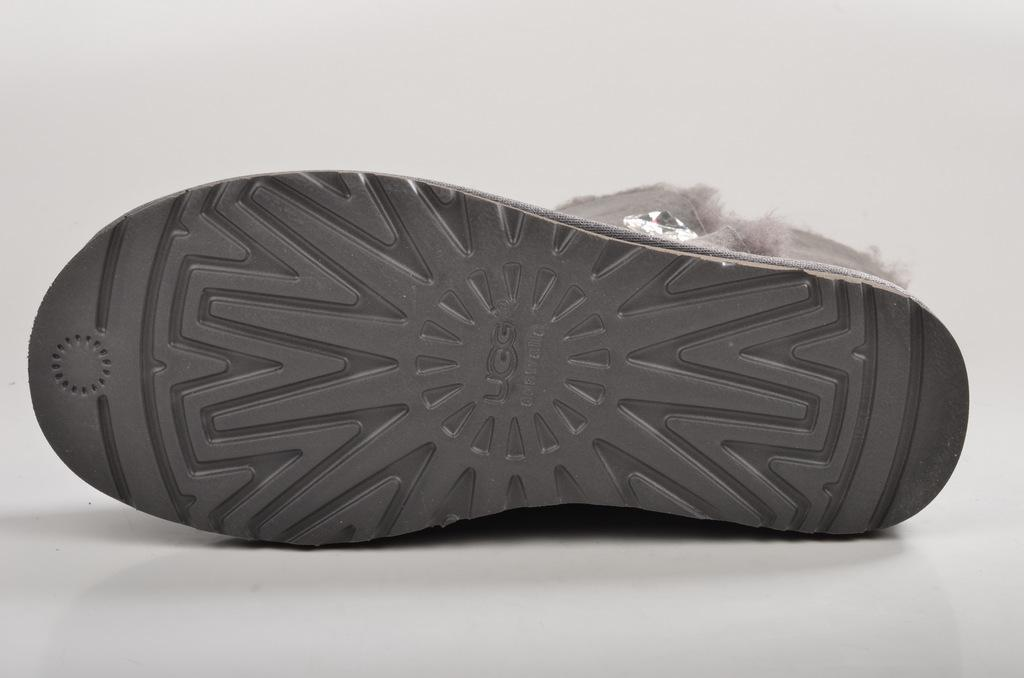What object is on the floor in the image? There is a shoe on the floor in the image. Can you describe the location of the shoe in the image? The shoe is on the floor. Where might this image have been taken? The image may have been taken in a room. What reward does the sister receive for finding the shoe in the image? There is no sister or reward mentioned in the image, and therefore no such interaction can be observed. 